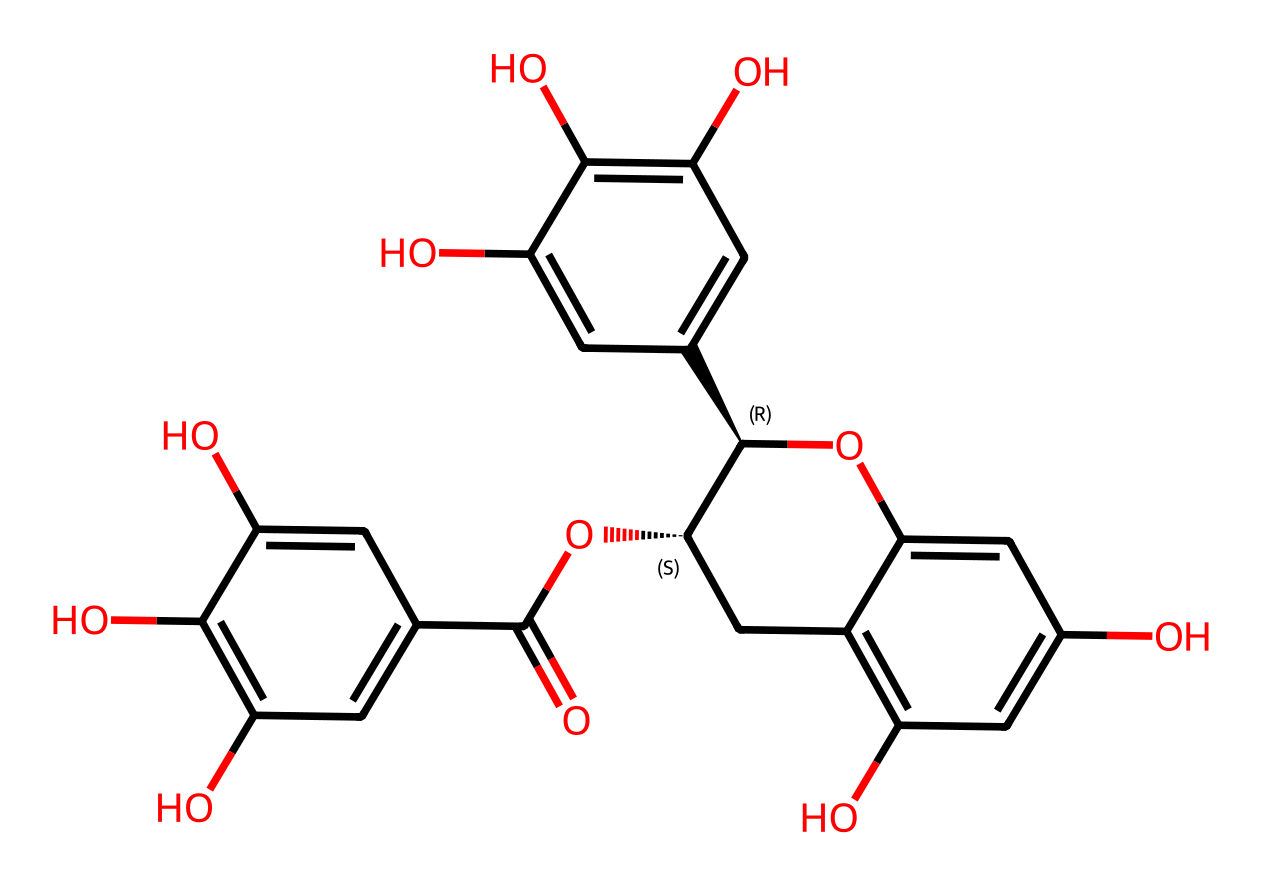What is the total number of carbon atoms in the structure? Count the number of carbon atoms (C) present in the chemical structure by analyzing each component in the SMILES representation. In this case, there are a total of 21 carbon atoms present.
Answer: 21 How many hydroxyl (–OH) groups are present in the molecule? Identify the functional groups by locating the hydroxyl groups in the structure. Each occurrence of 'O' that is bonded to 'H' corresponds to a hydroxyl group. In this structure, there are 7 hydroxyl groups identified.
Answer: 7 Does this compound contain any aromatic rings? Analyze the structure for cyclic sequences of carbon atoms with alternating double bonds or single bonds, which indicate aromaticity. EGCG contains 3 aromatic rings, confirming its aromatic nature.
Answer: 3 What is the molecular weight of epigallocatechin gallate (EGCG)? Use the atomic weights of its constituents found in the structure (C, H, O) and apply the empirical formula to determine the molecular weight. The calculated molecular weight of EGCG is 458.37 g/mol.
Answer: 458.37 g/mol Is EGCG a flavonoid? Check the structure for the characteristic features of flavonoids, which typically include a 15-carbon skeleton and phenolic structures. Given the structural elements present in EGCG, it qualifies as a flavonoid.
Answer: yes How many stereocenters are present in the molecule? Examine the carbons in the structure that have four different substituents, indicative of stereocenters. In the case of EGCG, there are 3 stereocenters identified based on the arrangement of substituents.
Answer: 3 